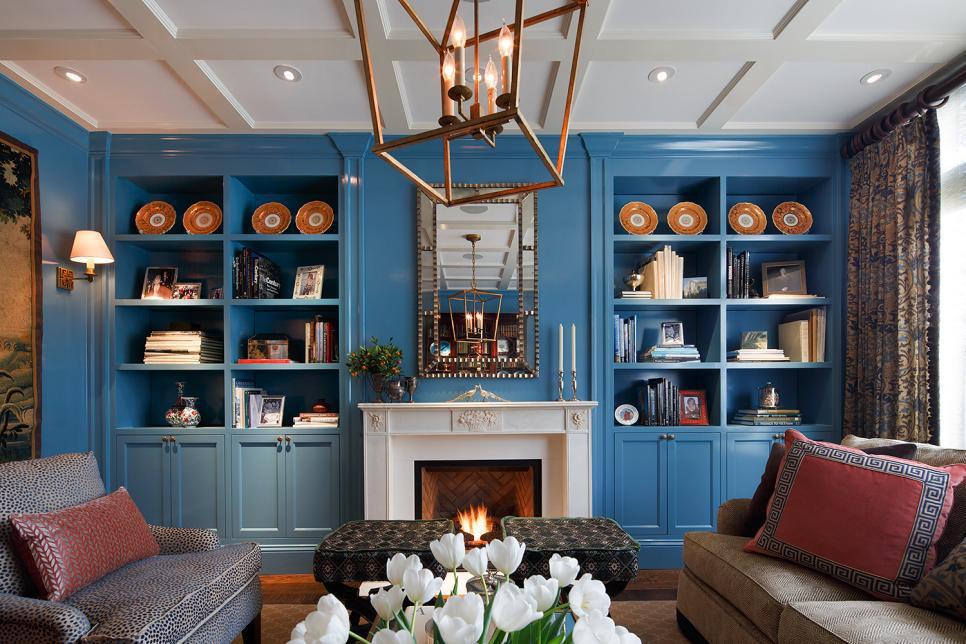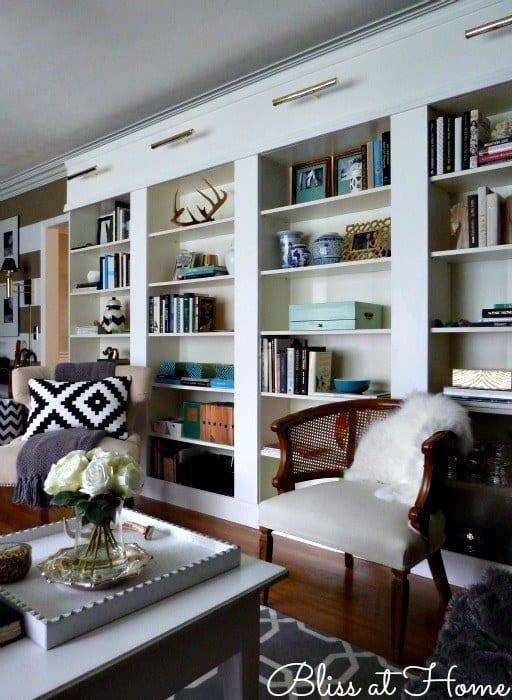The first image is the image on the left, the second image is the image on the right. For the images displayed, is the sentence "A light fixture is suspended at the center of the room in the right image." factually correct? Answer yes or no. No. The first image is the image on the left, the second image is the image on the right. For the images shown, is this caption "In one image, floor to ceiling shelving units flank a fire place." true? Answer yes or no. Yes. 